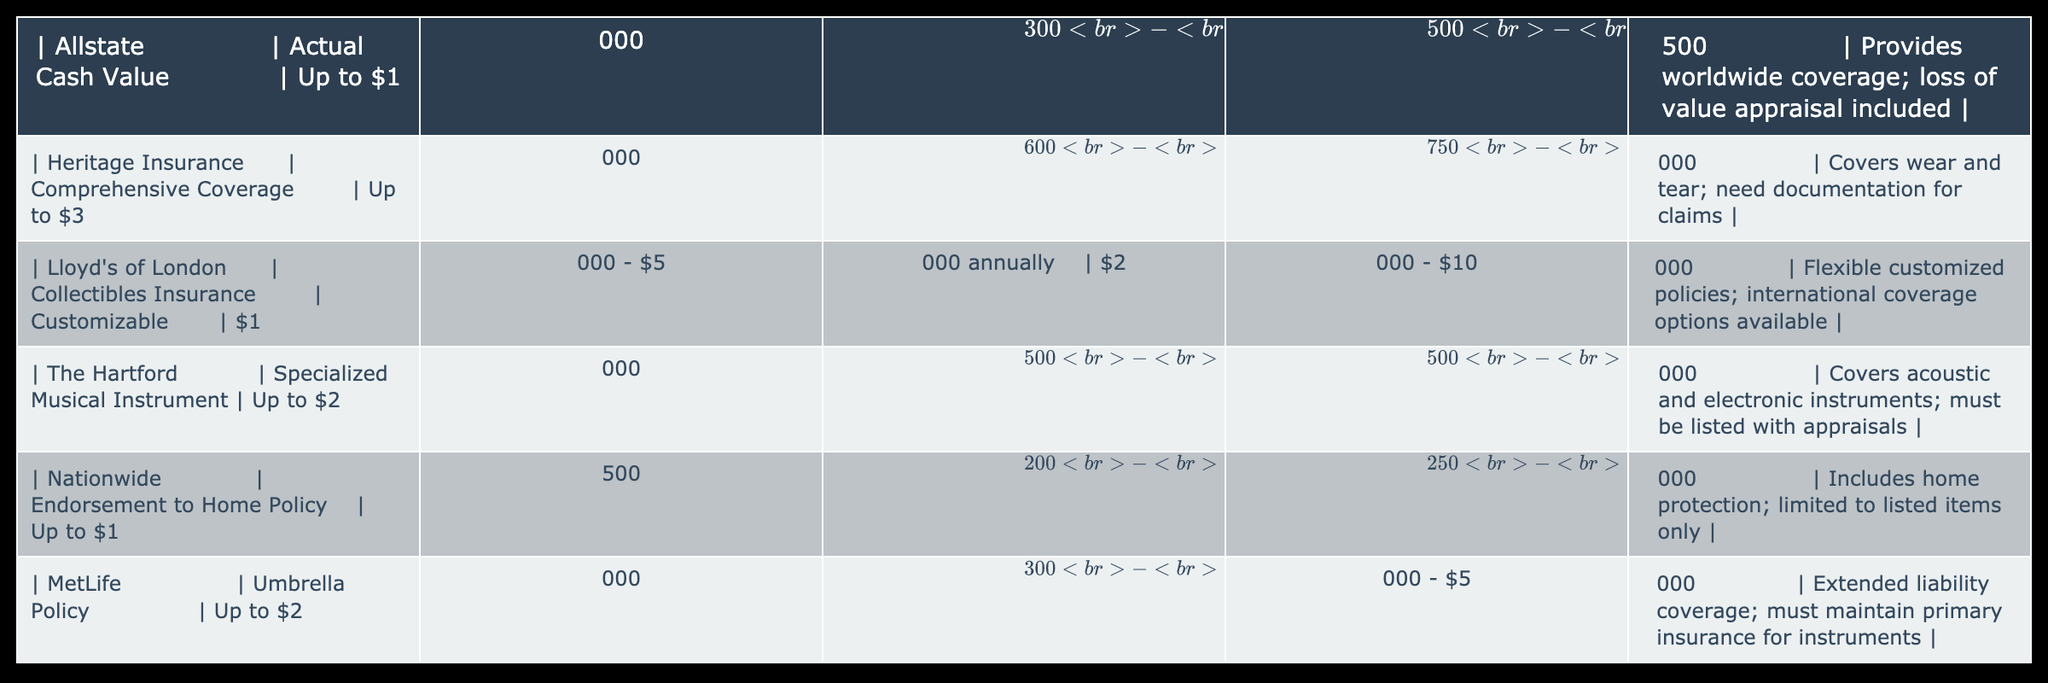What is the highest coverage amount offered by any insurance provider in the table? The coverage amounts listed in the table show "Up to $3,000,000" as the maximum coverage by Heritage Insurance. Thus, the highest coverage in the table is $3,000,000.
Answer: $3,000,000 Which insurance provider offers the lowest annual premium? By comparing the annual premiums listed, Nationwide offers the lowest premium with a range of "$200 - $1,200 annually." Therefore, it is the insurance provider with the lowest annual premium.
Answer: $200 Are there any providers that offer worldwide coverage? Upon reviewing the details, both Allstate and Lloyd's of London offer worldwide coverage options. This indicates that these providers allow coverage irrespective of the location.
Answer: Yes What is the average annual premium range for the insurance providers listed? To find the average annual premium range, we take the lowest values for each provider: $1,000 (Allstate), $600 (Heritage), $1,000 (Lloyd's), $500 (The Hartford), $200 (Nationwide), and $300 (MetLife). The total is $3,700, and there are 6 providers, so the average is $3,700 / 6 = $616.67. Taking the highest values: $1,500 + $1,800 + $5,000 + $1,700 + $1,200 + $900 = $12,100, leading to an average of $2,016.67. Hence, the average annual premium range is approximately $617 - $2,017.
Answer: $617 - $2,017 Which insurance policies specifically require documentation for claims? According to the details, Heritage Insurance requires documentation for claims. This means that an applicant must provide necessary paperwork to validate their claims under this policy.
Answer: Heritage Insurance What is the difference in maximum coverage between Allstate and The Hartford? The maximum coverage for Allstate is "$1,000,000," and for The Hartford, it is "$2,000,000." To find the difference, we subtract the two figures: $2,000,000 - $1,000,000 = $1,000,000. Hence, the difference in maximum coverage between these two providers is $1,000,000.
Answer: $1,000,000 Are all insurance policies listed in the table exclusively for musical instruments? The policies specifically for musical instruments are The Hartford and Lloyd's of London. Allstate, Heritage, Nationwide, and MetLife also have options, but not exclusively for musical instruments, indicating that not all policies are limited to musical instruments.
Answer: No Which insurance provider has a premium range that exceeds $1,000? By reviewing the premium ranges, it is evident that Heritage Insurance, Lloyd's of London, and The Hartford have premium ranges that exceed $1,000, making them the providers with higher premium options.
Answer: Heritage Insurance, Lloyd's of London, The Hartford 